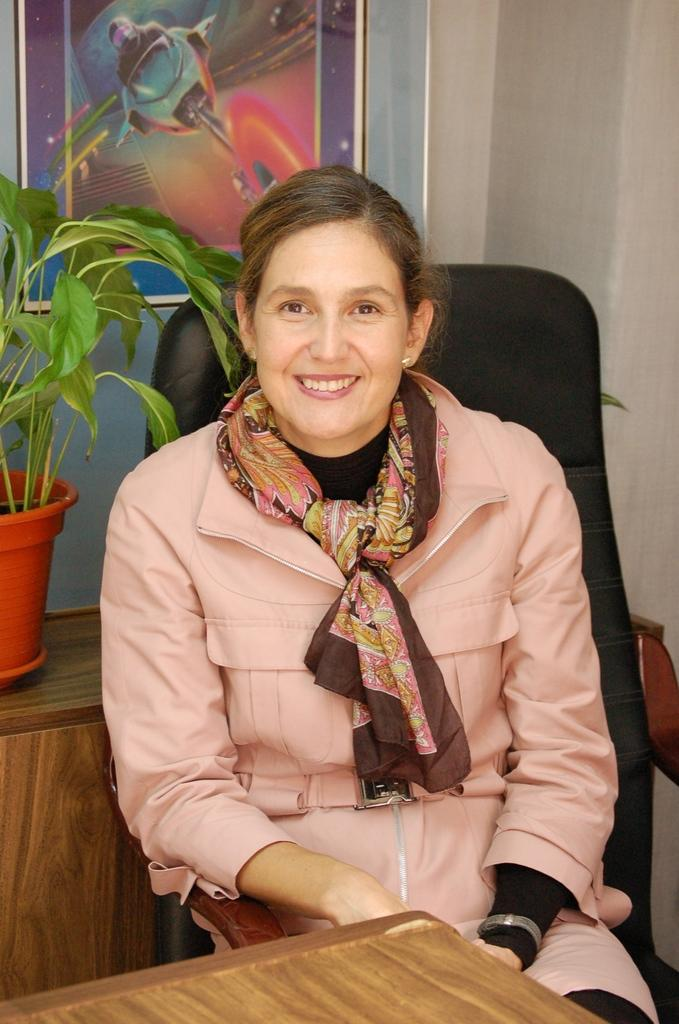What is the woman doing in the image? The woman is sitting on a chair in the image. What is in front of the woman? There is a table in front of the woman. What can be seen in the background of the image? There is a potted plant on a desk and a wall with a painting in the background. What type of system is the woman using to water the potted plant in the image? There is no system or hose visible in the image, and the woman is not shown watering the potted plant. 